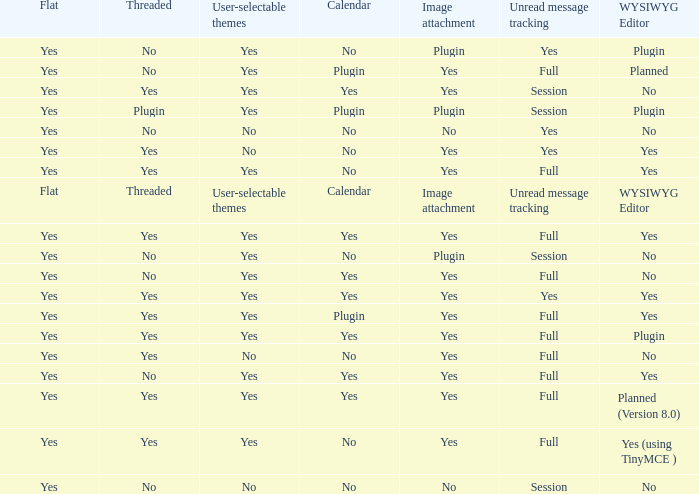Which Image attachment has a Threaded of yes, and a Calendar of yes? Yes, Yes, Yes, Yes, Yes. 